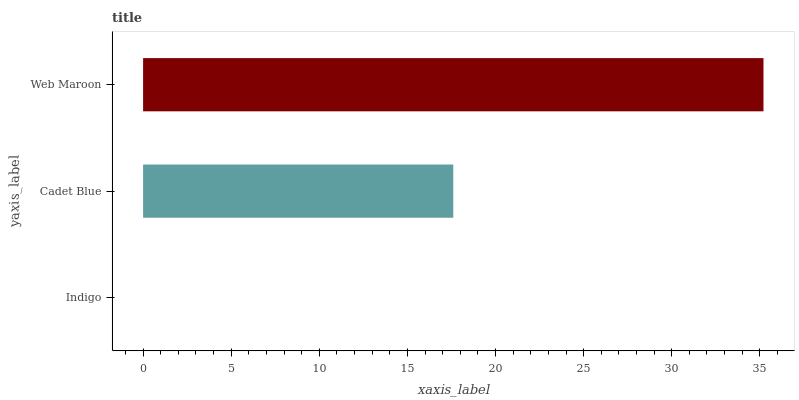Is Indigo the minimum?
Answer yes or no. Yes. Is Web Maroon the maximum?
Answer yes or no. Yes. Is Cadet Blue the minimum?
Answer yes or no. No. Is Cadet Blue the maximum?
Answer yes or no. No. Is Cadet Blue greater than Indigo?
Answer yes or no. Yes. Is Indigo less than Cadet Blue?
Answer yes or no. Yes. Is Indigo greater than Cadet Blue?
Answer yes or no. No. Is Cadet Blue less than Indigo?
Answer yes or no. No. Is Cadet Blue the high median?
Answer yes or no. Yes. Is Cadet Blue the low median?
Answer yes or no. Yes. Is Web Maroon the high median?
Answer yes or no. No. Is Indigo the low median?
Answer yes or no. No. 